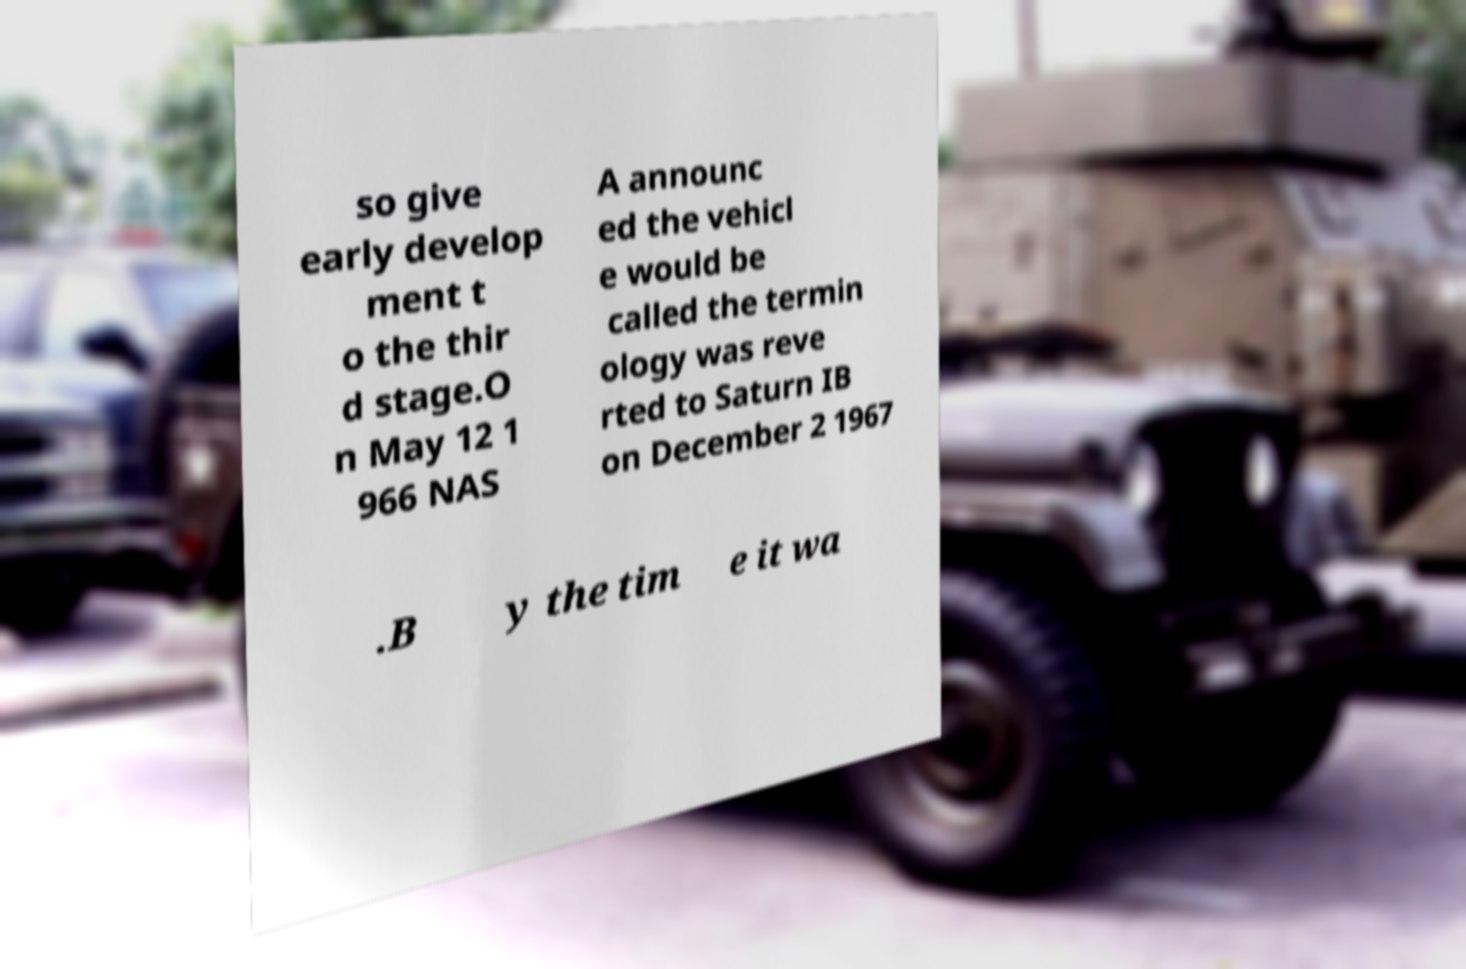For documentation purposes, I need the text within this image transcribed. Could you provide that? so give early develop ment t o the thir d stage.O n May 12 1 966 NAS A announc ed the vehicl e would be called the termin ology was reve rted to Saturn IB on December 2 1967 .B y the tim e it wa 